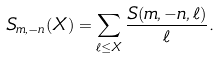Convert formula to latex. <formula><loc_0><loc_0><loc_500><loc_500>S _ { m , - n } ( X ) = \sum _ { \ell \leq X } \frac { S ( m , - n , \ell ) } { \ell } .</formula> 